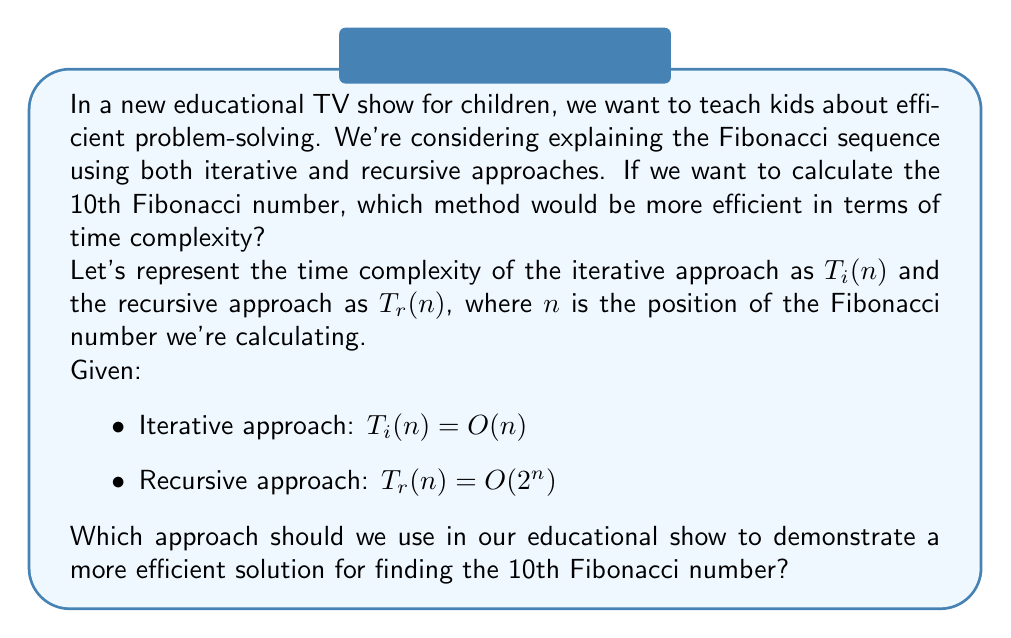Could you help me with this problem? To determine which approach is more efficient, we need to compare the time complexities of both methods:

1. Iterative approach: $T_i(n) = O(n)$
   This means the time complexity grows linearly with the input size.

2. Recursive approach: $T_r(n) = O(2^n)$
   This means the time complexity grows exponentially with the input size.

For $n = 10$ (the 10th Fibonacci number):

1. Iterative: $T_i(10) = O(10)$
2. Recursive: $T_r(10) = O(2^{10}) = O(1024)$

Comparing these values:

$$ O(10) << O(1024) $$

The iterative approach is significantly more efficient for $n = 10$, and this difference becomes even more pronounced as $n$ increases.

In terms of educational value:
1. The iterative approach demonstrates a more efficient solution, which is an important concept in algorithm design.
2. It provides an opportunity to explain why some solutions, while seemingly simpler (like recursion), can be less efficient.
3. It allows for a discussion on how to improve algorithms and think critically about problem-solving methods.

Therefore, for our educational TV show, we should use the iterative approach to demonstrate a more efficient solution for finding the 10th Fibonacci number.
Answer: Iterative approach 